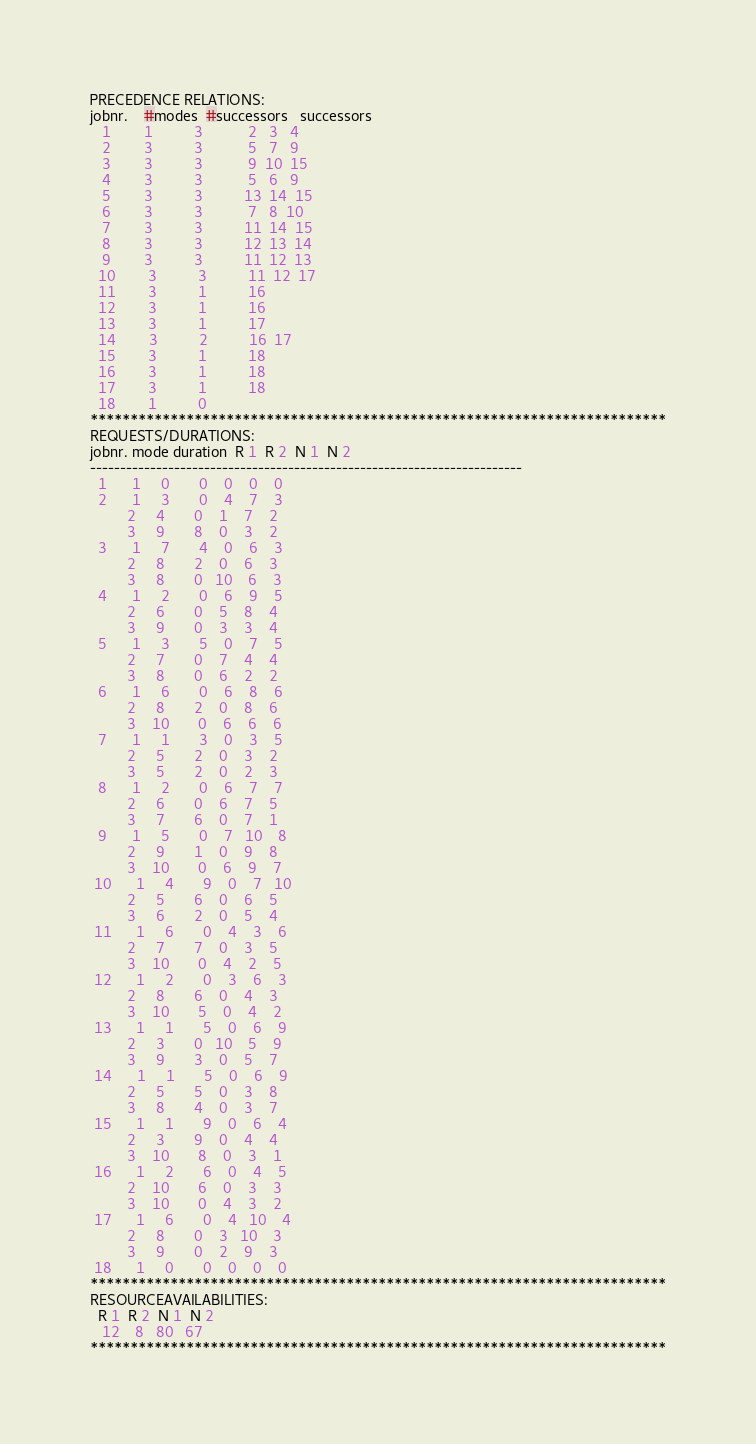<code> <loc_0><loc_0><loc_500><loc_500><_ObjectiveC_>PRECEDENCE RELATIONS:
jobnr.    #modes  #successors   successors
   1        1          3           2   3   4
   2        3          3           5   7   9
   3        3          3           9  10  15
   4        3          3           5   6   9
   5        3          3          13  14  15
   6        3          3           7   8  10
   7        3          3          11  14  15
   8        3          3          12  13  14
   9        3          3          11  12  13
  10        3          3          11  12  17
  11        3          1          16
  12        3          1          16
  13        3          1          17
  14        3          2          16  17
  15        3          1          18
  16        3          1          18
  17        3          1          18
  18        1          0        
************************************************************************
REQUESTS/DURATIONS:
jobnr. mode duration  R 1  R 2  N 1  N 2
------------------------------------------------------------------------
  1      1     0       0    0    0    0
  2      1     3       0    4    7    3
         2     4       0    1    7    2
         3     9       8    0    3    2
  3      1     7       4    0    6    3
         2     8       2    0    6    3
         3     8       0   10    6    3
  4      1     2       0    6    9    5
         2     6       0    5    8    4
         3     9       0    3    3    4
  5      1     3       5    0    7    5
         2     7       0    7    4    4
         3     8       0    6    2    2
  6      1     6       0    6    8    6
         2     8       2    0    8    6
         3    10       0    6    6    6
  7      1     1       3    0    3    5
         2     5       2    0    3    2
         3     5       2    0    2    3
  8      1     2       0    6    7    7
         2     6       0    6    7    5
         3     7       6    0    7    1
  9      1     5       0    7   10    8
         2     9       1    0    9    8
         3    10       0    6    9    7
 10      1     4       9    0    7   10
         2     5       6    0    6    5
         3     6       2    0    5    4
 11      1     6       0    4    3    6
         2     7       7    0    3    5
         3    10       0    4    2    5
 12      1     2       0    3    6    3
         2     8       6    0    4    3
         3    10       5    0    4    2
 13      1     1       5    0    6    9
         2     3       0   10    5    9
         3     9       3    0    5    7
 14      1     1       5    0    6    9
         2     5       5    0    3    8
         3     8       4    0    3    7
 15      1     1       9    0    6    4
         2     3       9    0    4    4
         3    10       8    0    3    1
 16      1     2       6    0    4    5
         2    10       6    0    3    3
         3    10       0    4    3    2
 17      1     6       0    4   10    4
         2     8       0    3   10    3
         3     9       0    2    9    3
 18      1     0       0    0    0    0
************************************************************************
RESOURCEAVAILABILITIES:
  R 1  R 2  N 1  N 2
   12    8   80   67
************************************************************************
</code> 